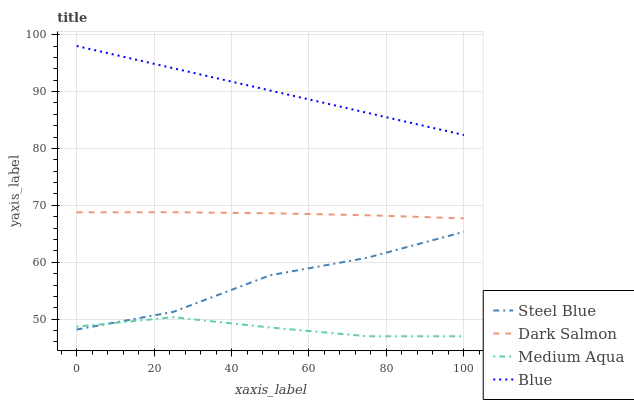Does Steel Blue have the minimum area under the curve?
Answer yes or no. No. Does Steel Blue have the maximum area under the curve?
Answer yes or no. No. Is Medium Aqua the smoothest?
Answer yes or no. No. Is Medium Aqua the roughest?
Answer yes or no. No. Does Steel Blue have the lowest value?
Answer yes or no. No. Does Steel Blue have the highest value?
Answer yes or no. No. Is Medium Aqua less than Blue?
Answer yes or no. Yes. Is Dark Salmon greater than Medium Aqua?
Answer yes or no. Yes. Does Medium Aqua intersect Blue?
Answer yes or no. No. 